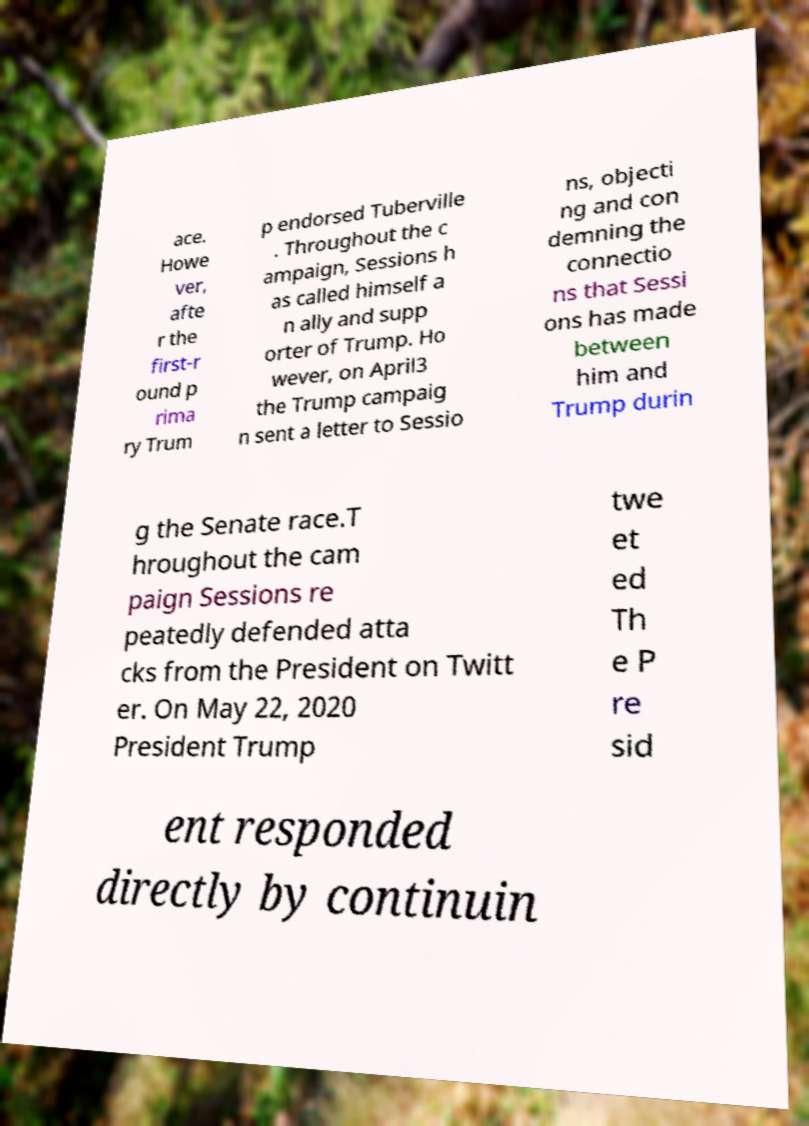Can you accurately transcribe the text from the provided image for me? ace. Howe ver, afte r the first-r ound p rima ry Trum p endorsed Tuberville . Throughout the c ampaign, Sessions h as called himself a n ally and supp orter of Trump. Ho wever, on April3 the Trump campaig n sent a letter to Sessio ns, objecti ng and con demning the connectio ns that Sessi ons has made between him and Trump durin g the Senate race.T hroughout the cam paign Sessions re peatedly defended atta cks from the President on Twitt er. On May 22, 2020 President Trump twe et ed Th e P re sid ent responded directly by continuin 